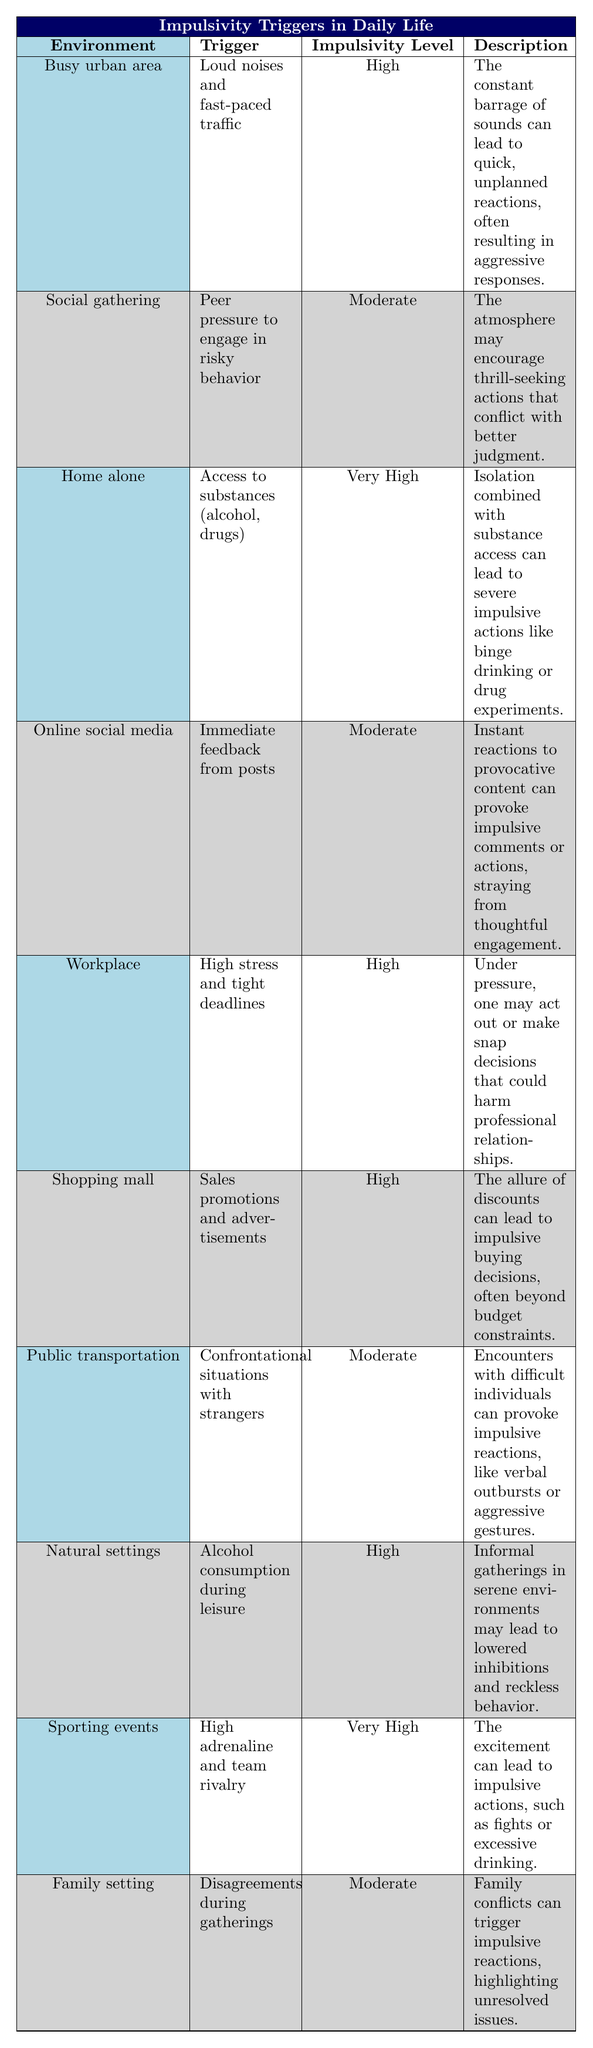What is the trigger for impulsivity in a busy urban area? According to the table, the trigger listed for a busy urban area is "Loud noises and fast-paced traffic."
Answer: Loud noises and fast-paced traffic Which environment has the highest impulsivity level? The data shows that "Home alone" and "Sporting events" have a very high impulsivity level.
Answer: Home alone and Sporting events Are there any environments where the impulsivity level is moderate? Yes, the table lists "Social gathering," "Online social media," "Public transportation," and "Family setting" as having a moderate impulsivity level.
Answer: Yes What is the description of triggers leading to impulsivity in a shopping mall? The table states that in a shopping mall, the description is "The allure of discounts can lead to impulsive buying decisions, often beyond budget constraints."
Answer: The allure of discounts can lead to impulsive buying decisions, often beyond budget constraints How many environments have a high impulsivity level? The environments with a high impulsivity level are "Busy urban area," "Workplace," "Shopping mall," and "Natural settings." There are four environments in total.
Answer: Four Does the environment of sporting events lead to impulsive actions related to alcohol consumption? The table describes that impulsivity at sporting events is related to "High adrenaline and team rivalry," while alcohol consumption is mentioned under "Natural settings." Therefore, the answer is no.
Answer: No Which environments have triggers that specifically involve peer pressure? The only environment that mentions peer pressure is the "Social gathering," which states a trigger of "Peer pressure to engage in risky behavior."
Answer: Social gathering What is the overall trend in impulsivity levels related to environments involving high levels of stress or conflict? The table indicates that both "Workplace" and "Public transportation" environments have high stress that correlates with impulsivity levels, as well as "Family setting" experiencing disagreements leading to moderate impulsivity.
Answer: High stress and conflict correlate with impulsivity in several environments 